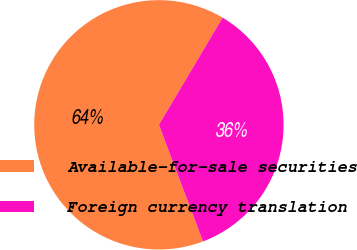Convert chart to OTSL. <chart><loc_0><loc_0><loc_500><loc_500><pie_chart><fcel>Available-for-sale securities<fcel>Foreign currency translation<nl><fcel>64.29%<fcel>35.71%<nl></chart> 